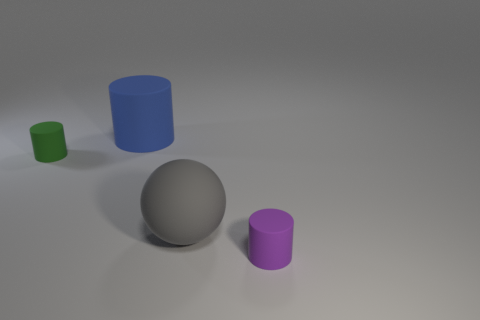Are there any small cylinders that are to the left of the large rubber object that is behind the small rubber object that is behind the purple matte object?
Offer a very short reply. Yes. There is a tiny thing on the right side of the big ball; is its shape the same as the big gray matte object?
Offer a very short reply. No. What is the shape of the tiny object to the left of the object in front of the gray thing?
Provide a succinct answer. Cylinder. What size is the matte cylinder right of the rubber cylinder behind the tiny matte thing that is behind the purple matte cylinder?
Provide a short and direct response. Small. The other big rubber thing that is the same shape as the green rubber thing is what color?
Your answer should be compact. Blue. Is the gray object the same size as the blue matte cylinder?
Your answer should be compact. Yes. There is a big thing to the left of the gray object; what material is it?
Your answer should be very brief. Rubber. What number of other objects are there of the same shape as the big gray rubber thing?
Make the answer very short. 0. Does the green thing have the same shape as the blue rubber thing?
Provide a short and direct response. Yes. Are there any large things in front of the big blue matte thing?
Keep it short and to the point. Yes. 